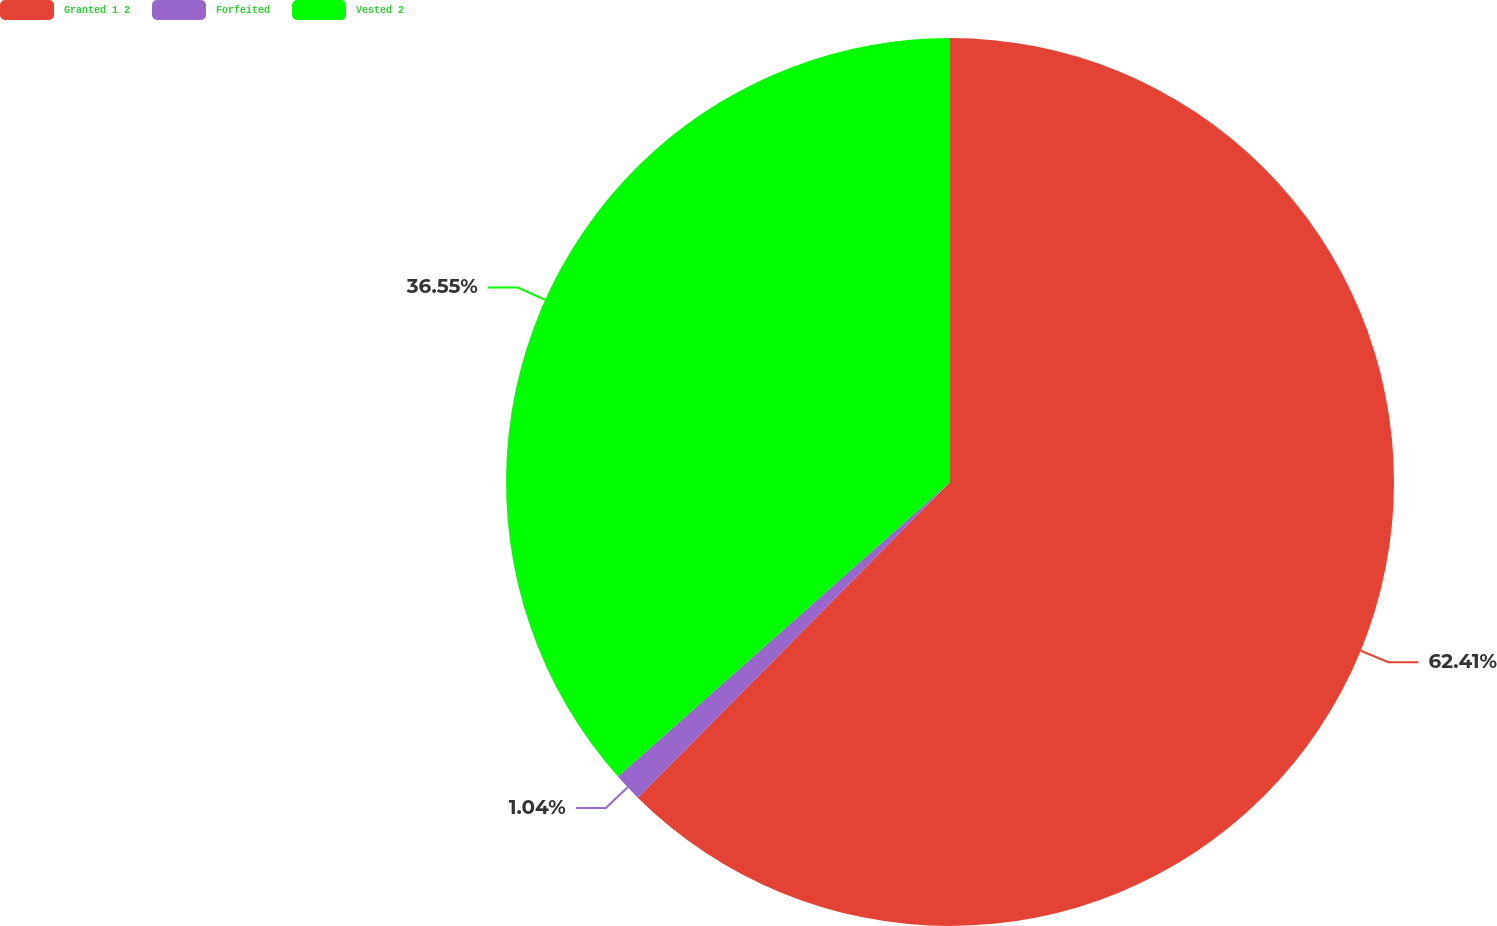Convert chart to OTSL. <chart><loc_0><loc_0><loc_500><loc_500><pie_chart><fcel>Granted 1 2<fcel>Forfeited<fcel>Vested 2<nl><fcel>62.42%<fcel>1.04%<fcel>36.55%<nl></chart> 